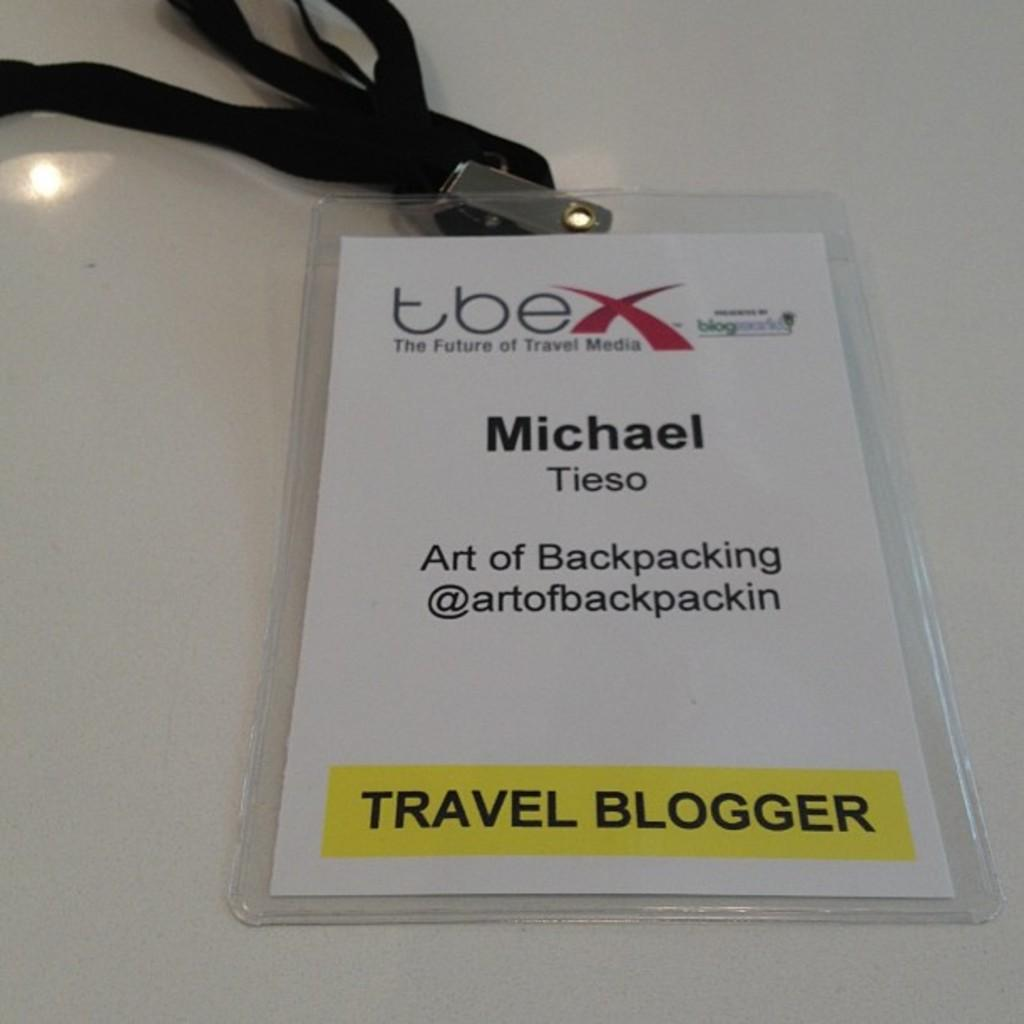What object is the main focus of the image? There is an identity card in the image. What information can be found on the identity card? The identity card belongs to a person working as a travel blogger. What story is the identity card telling in the image? The identity card is not telling a story in the image; it is simply a form of identification for a travel blogger. 